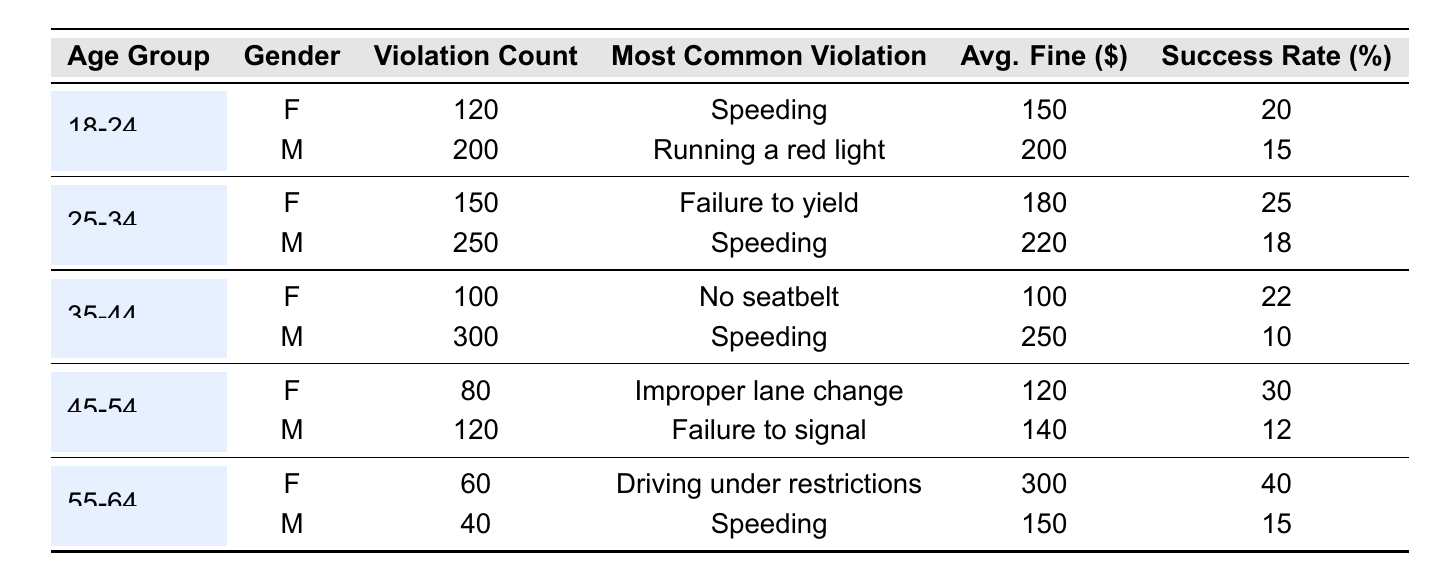What is the most common violation for males aged 25-34? From the table, for the age group 25-34 and gender Male, the most common violation listed is "Speeding."
Answer: Speeding How many total violations were recorded for females in the 18-24 and 25-34 age groups combined? For females aged 18-24, violation count is 120, and for 25-34, it is 150. Summing these gives 120 + 150 = 270.
Answer: 270 Which age group has the highest average fine among females? The average fines for females are: 18-24 ($150), 25-34 ($180), 35-44 ($100), 45-54 ($120), and 55-64 ($300). The highest value is 300 for the 55-64 age group.
Answer: 55-64 What is the success rate for contested tickets for males aged 35-44? From the table, the success rate for males in the 35-44 age group is listed as 10%.
Answer: 10% Which gender and age group had the lowest violation count? Looking through the table, the lowest violation count is 40, which corresponds to males aged 55-64.
Answer: Male, 55-64 What is the total number of contested tickets across all age groups for females? The contested tickets for females are: 30 (18-24) + 40 (25-34) + 20 (35-44) + 10 (45-54) + 5 (55-64), summing these gives 30 + 40 + 20 + 10 + 5 = 105.
Answer: 105 Are there more contested tickets from males or females in the age group 45-54? For males 45-54, there are 25 contested tickets, and for females, there are 10. Since 25 is greater than 10, males have more contested tickets.
Answer: Yes What percentage of contested tickets for females aged 55-64 were successful? For females 55-64, the success rate is listed as 40%.
Answer: 40% In which age group do females have the highest success rate for contested tickets? Examining the success rates for females: 20% (18-24), 25% (25-34), 22% (35-44), 30% (45-54), and 40% (55-64). The highest is 40% for 55-64.
Answer: 55-64 What is the average fine for the most common violation among males in the 25-34 age group? The most common violation for males aged 25-34 is "Speeding", and the average fine associated with it is $220.
Answer: $220 